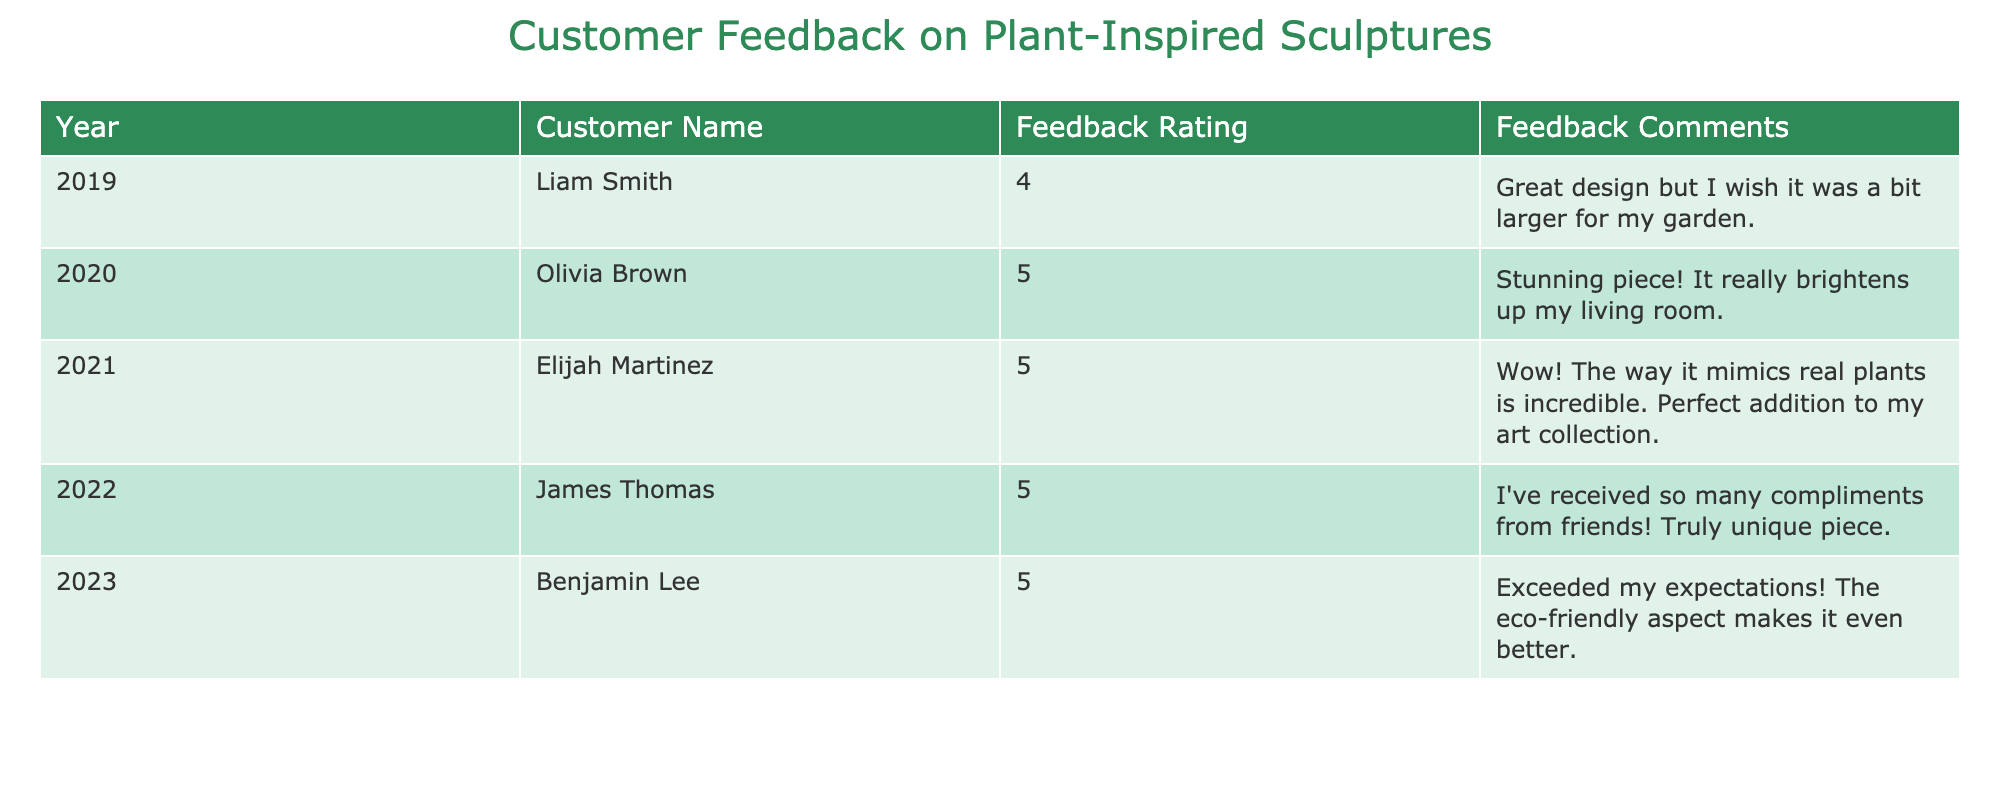what is the feedback rating given by Elijah Martinez? In the table, the row for Elijah Martinez shows that his feedback rating is stated clearly within the "Feedback Rating" column. By locating his name in the "Customer Name" column, we can directly read across to find the matching feedback rating.
Answer: 5 how many customers rated their experience as 5? To find this, I can count the occurrences of the rating '5' in the "Feedback Rating" column. In this case, there are 4 customers who gave this rating (Olivia Brown, Elijah Martinez, James Thomas, and Benjamin Lee).
Answer: 4 what is the feedback comment from Liam Smith? The table lists Liam Smith in the "Customer Name" column. By checking the same row, I can see that his feedback comment is found in the corresponding "Feedback Comments" column.
Answer: Great design but I wish it was a bit larger for my garden what is the average rating from customer feedback? To calculate the average, I first sum the feedback ratings: 4 + 5 + 5 + 5 + 5 = 24. Since there are 5 customers, I then divide the total by 5: 24/5 = 4.8. This gives me the average feedback rating.
Answer: 4.8 did any customer express dissatisfaction with their sculpture? Looking through the "Feedback Comments" for any negative language or mentions of dissatisfaction can help. In this case, all comments are positive, with no one expressing dissatisfaction.
Answer: No which year had the highest feedback rating? I analyze the "Feedback Rating" column for the years: 2019 has a rating of 4, while 2020, 2021, 2022, and 2023 all have ratings of 5. The highest rating of 5 corresponds to the years 2020, 2021, 2022, and 2023.
Answer: 2020, 2021, 2022, and 2023 how many years received a 5-star rating? Reviewing the feedback ratings across all years listed, I see that the years 2020, 2021, 2022, and 2023 received a rating of 5. Counting these years gives a total of 4 years with a 5-star rating.
Answer: 4 what is the feedback comment from the most recent customer? By looking at the year column, the most recent customer listed is Benjamin Lee from 2023. I then check the corresponding feedback comment for his entry, which is in the "Feedback Comments" column.
Answer: Exceeded my expectations! The eco-friendly aspect makes it even better 